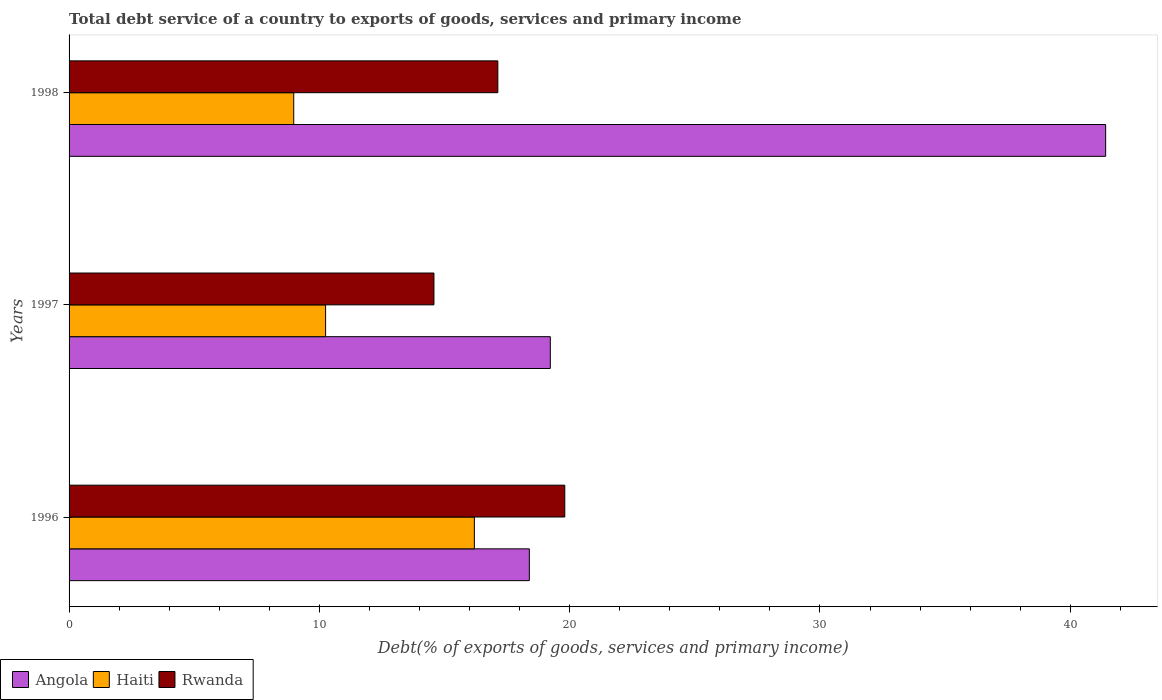Are the number of bars per tick equal to the number of legend labels?
Offer a terse response. Yes. Are the number of bars on each tick of the Y-axis equal?
Provide a short and direct response. Yes. What is the total debt service in Angola in 1997?
Your answer should be very brief. 19.23. Across all years, what is the maximum total debt service in Haiti?
Give a very brief answer. 16.19. Across all years, what is the minimum total debt service in Rwanda?
Ensure brevity in your answer.  14.58. In which year was the total debt service in Haiti minimum?
Your answer should be compact. 1998. What is the total total debt service in Haiti in the graph?
Your answer should be compact. 35.42. What is the difference between the total debt service in Haiti in 1996 and that in 1998?
Offer a very short reply. 7.22. What is the difference between the total debt service in Angola in 1996 and the total debt service in Haiti in 1997?
Make the answer very short. 8.14. What is the average total debt service in Haiti per year?
Make the answer very short. 11.81. In the year 1998, what is the difference between the total debt service in Angola and total debt service in Rwanda?
Your response must be concise. 24.28. What is the ratio of the total debt service in Haiti in 1997 to that in 1998?
Make the answer very short. 1.14. What is the difference between the highest and the second highest total debt service in Angola?
Your answer should be very brief. 22.19. What is the difference between the highest and the lowest total debt service in Haiti?
Provide a short and direct response. 7.22. In how many years, is the total debt service in Angola greater than the average total debt service in Angola taken over all years?
Offer a terse response. 1. What does the 3rd bar from the top in 1997 represents?
Provide a succinct answer. Angola. What does the 1st bar from the bottom in 1996 represents?
Keep it short and to the point. Angola. Is it the case that in every year, the sum of the total debt service in Haiti and total debt service in Angola is greater than the total debt service in Rwanda?
Offer a terse response. Yes. How many bars are there?
Offer a very short reply. 9. Are all the bars in the graph horizontal?
Provide a succinct answer. Yes. What is the difference between two consecutive major ticks on the X-axis?
Ensure brevity in your answer.  10. Are the values on the major ticks of X-axis written in scientific E-notation?
Your answer should be very brief. No. Does the graph contain grids?
Offer a terse response. No. How are the legend labels stacked?
Ensure brevity in your answer.  Horizontal. What is the title of the graph?
Offer a very short reply. Total debt service of a country to exports of goods, services and primary income. Does "Barbados" appear as one of the legend labels in the graph?
Make the answer very short. No. What is the label or title of the X-axis?
Provide a succinct answer. Debt(% of exports of goods, services and primary income). What is the label or title of the Y-axis?
Make the answer very short. Years. What is the Debt(% of exports of goods, services and primary income) of Angola in 1996?
Your response must be concise. 18.39. What is the Debt(% of exports of goods, services and primary income) in Haiti in 1996?
Your answer should be very brief. 16.19. What is the Debt(% of exports of goods, services and primary income) of Rwanda in 1996?
Ensure brevity in your answer.  19.81. What is the Debt(% of exports of goods, services and primary income) of Angola in 1997?
Offer a terse response. 19.23. What is the Debt(% of exports of goods, services and primary income) in Haiti in 1997?
Keep it short and to the point. 10.25. What is the Debt(% of exports of goods, services and primary income) of Rwanda in 1997?
Give a very brief answer. 14.58. What is the Debt(% of exports of goods, services and primary income) of Angola in 1998?
Offer a very short reply. 41.42. What is the Debt(% of exports of goods, services and primary income) in Haiti in 1998?
Offer a very short reply. 8.98. What is the Debt(% of exports of goods, services and primary income) in Rwanda in 1998?
Your answer should be very brief. 17.13. Across all years, what is the maximum Debt(% of exports of goods, services and primary income) of Angola?
Provide a succinct answer. 41.42. Across all years, what is the maximum Debt(% of exports of goods, services and primary income) in Haiti?
Your answer should be compact. 16.19. Across all years, what is the maximum Debt(% of exports of goods, services and primary income) of Rwanda?
Your answer should be compact. 19.81. Across all years, what is the minimum Debt(% of exports of goods, services and primary income) in Angola?
Your response must be concise. 18.39. Across all years, what is the minimum Debt(% of exports of goods, services and primary income) of Haiti?
Your response must be concise. 8.98. Across all years, what is the minimum Debt(% of exports of goods, services and primary income) of Rwanda?
Offer a very short reply. 14.58. What is the total Debt(% of exports of goods, services and primary income) of Angola in the graph?
Make the answer very short. 79.03. What is the total Debt(% of exports of goods, services and primary income) of Haiti in the graph?
Make the answer very short. 35.42. What is the total Debt(% of exports of goods, services and primary income) of Rwanda in the graph?
Make the answer very short. 51.51. What is the difference between the Debt(% of exports of goods, services and primary income) in Angola in 1996 and that in 1997?
Your answer should be compact. -0.84. What is the difference between the Debt(% of exports of goods, services and primary income) of Haiti in 1996 and that in 1997?
Give a very brief answer. 5.94. What is the difference between the Debt(% of exports of goods, services and primary income) in Rwanda in 1996 and that in 1997?
Ensure brevity in your answer.  5.23. What is the difference between the Debt(% of exports of goods, services and primary income) of Angola in 1996 and that in 1998?
Offer a terse response. -23.03. What is the difference between the Debt(% of exports of goods, services and primary income) in Haiti in 1996 and that in 1998?
Ensure brevity in your answer.  7.22. What is the difference between the Debt(% of exports of goods, services and primary income) in Rwanda in 1996 and that in 1998?
Your answer should be very brief. 2.67. What is the difference between the Debt(% of exports of goods, services and primary income) of Angola in 1997 and that in 1998?
Your answer should be compact. -22.19. What is the difference between the Debt(% of exports of goods, services and primary income) of Haiti in 1997 and that in 1998?
Offer a very short reply. 1.27. What is the difference between the Debt(% of exports of goods, services and primary income) in Rwanda in 1997 and that in 1998?
Provide a succinct answer. -2.55. What is the difference between the Debt(% of exports of goods, services and primary income) of Angola in 1996 and the Debt(% of exports of goods, services and primary income) of Haiti in 1997?
Keep it short and to the point. 8.14. What is the difference between the Debt(% of exports of goods, services and primary income) in Angola in 1996 and the Debt(% of exports of goods, services and primary income) in Rwanda in 1997?
Your response must be concise. 3.81. What is the difference between the Debt(% of exports of goods, services and primary income) of Haiti in 1996 and the Debt(% of exports of goods, services and primary income) of Rwanda in 1997?
Your response must be concise. 1.61. What is the difference between the Debt(% of exports of goods, services and primary income) of Angola in 1996 and the Debt(% of exports of goods, services and primary income) of Haiti in 1998?
Make the answer very short. 9.41. What is the difference between the Debt(% of exports of goods, services and primary income) in Angola in 1996 and the Debt(% of exports of goods, services and primary income) in Rwanda in 1998?
Provide a succinct answer. 1.26. What is the difference between the Debt(% of exports of goods, services and primary income) of Haiti in 1996 and the Debt(% of exports of goods, services and primary income) of Rwanda in 1998?
Ensure brevity in your answer.  -0.94. What is the difference between the Debt(% of exports of goods, services and primary income) in Angola in 1997 and the Debt(% of exports of goods, services and primary income) in Haiti in 1998?
Offer a very short reply. 10.25. What is the difference between the Debt(% of exports of goods, services and primary income) of Angola in 1997 and the Debt(% of exports of goods, services and primary income) of Rwanda in 1998?
Offer a very short reply. 2.1. What is the difference between the Debt(% of exports of goods, services and primary income) of Haiti in 1997 and the Debt(% of exports of goods, services and primary income) of Rwanda in 1998?
Ensure brevity in your answer.  -6.88. What is the average Debt(% of exports of goods, services and primary income) of Angola per year?
Your answer should be very brief. 26.34. What is the average Debt(% of exports of goods, services and primary income) of Haiti per year?
Keep it short and to the point. 11.81. What is the average Debt(% of exports of goods, services and primary income) of Rwanda per year?
Ensure brevity in your answer.  17.17. In the year 1996, what is the difference between the Debt(% of exports of goods, services and primary income) of Angola and Debt(% of exports of goods, services and primary income) of Haiti?
Offer a terse response. 2.2. In the year 1996, what is the difference between the Debt(% of exports of goods, services and primary income) in Angola and Debt(% of exports of goods, services and primary income) in Rwanda?
Provide a succinct answer. -1.42. In the year 1996, what is the difference between the Debt(% of exports of goods, services and primary income) in Haiti and Debt(% of exports of goods, services and primary income) in Rwanda?
Keep it short and to the point. -3.61. In the year 1997, what is the difference between the Debt(% of exports of goods, services and primary income) of Angola and Debt(% of exports of goods, services and primary income) of Haiti?
Provide a succinct answer. 8.98. In the year 1997, what is the difference between the Debt(% of exports of goods, services and primary income) of Angola and Debt(% of exports of goods, services and primary income) of Rwanda?
Your answer should be very brief. 4.65. In the year 1997, what is the difference between the Debt(% of exports of goods, services and primary income) of Haiti and Debt(% of exports of goods, services and primary income) of Rwanda?
Ensure brevity in your answer.  -4.33. In the year 1998, what is the difference between the Debt(% of exports of goods, services and primary income) in Angola and Debt(% of exports of goods, services and primary income) in Haiti?
Ensure brevity in your answer.  32.44. In the year 1998, what is the difference between the Debt(% of exports of goods, services and primary income) in Angola and Debt(% of exports of goods, services and primary income) in Rwanda?
Your answer should be very brief. 24.28. In the year 1998, what is the difference between the Debt(% of exports of goods, services and primary income) of Haiti and Debt(% of exports of goods, services and primary income) of Rwanda?
Provide a succinct answer. -8.15. What is the ratio of the Debt(% of exports of goods, services and primary income) of Angola in 1996 to that in 1997?
Ensure brevity in your answer.  0.96. What is the ratio of the Debt(% of exports of goods, services and primary income) in Haiti in 1996 to that in 1997?
Your response must be concise. 1.58. What is the ratio of the Debt(% of exports of goods, services and primary income) of Rwanda in 1996 to that in 1997?
Your answer should be very brief. 1.36. What is the ratio of the Debt(% of exports of goods, services and primary income) in Angola in 1996 to that in 1998?
Your answer should be compact. 0.44. What is the ratio of the Debt(% of exports of goods, services and primary income) in Haiti in 1996 to that in 1998?
Offer a terse response. 1.8. What is the ratio of the Debt(% of exports of goods, services and primary income) of Rwanda in 1996 to that in 1998?
Your response must be concise. 1.16. What is the ratio of the Debt(% of exports of goods, services and primary income) of Angola in 1997 to that in 1998?
Provide a short and direct response. 0.46. What is the ratio of the Debt(% of exports of goods, services and primary income) of Haiti in 1997 to that in 1998?
Offer a very short reply. 1.14. What is the ratio of the Debt(% of exports of goods, services and primary income) of Rwanda in 1997 to that in 1998?
Ensure brevity in your answer.  0.85. What is the difference between the highest and the second highest Debt(% of exports of goods, services and primary income) in Angola?
Keep it short and to the point. 22.19. What is the difference between the highest and the second highest Debt(% of exports of goods, services and primary income) in Haiti?
Your answer should be very brief. 5.94. What is the difference between the highest and the second highest Debt(% of exports of goods, services and primary income) of Rwanda?
Your answer should be very brief. 2.67. What is the difference between the highest and the lowest Debt(% of exports of goods, services and primary income) in Angola?
Ensure brevity in your answer.  23.03. What is the difference between the highest and the lowest Debt(% of exports of goods, services and primary income) of Haiti?
Provide a short and direct response. 7.22. What is the difference between the highest and the lowest Debt(% of exports of goods, services and primary income) in Rwanda?
Offer a very short reply. 5.23. 